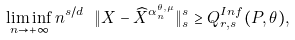<formula> <loc_0><loc_0><loc_500><loc_500>\liminf _ { n \rightarrow + \infty } n ^ { s / d } \ \| X - \widehat { X } ^ { \alpha _ { n } ^ { \theta , \mu } } \| _ { s } ^ { s } \geq Q _ { r , s } ^ { I n f } ( P , \theta ) ,</formula> 